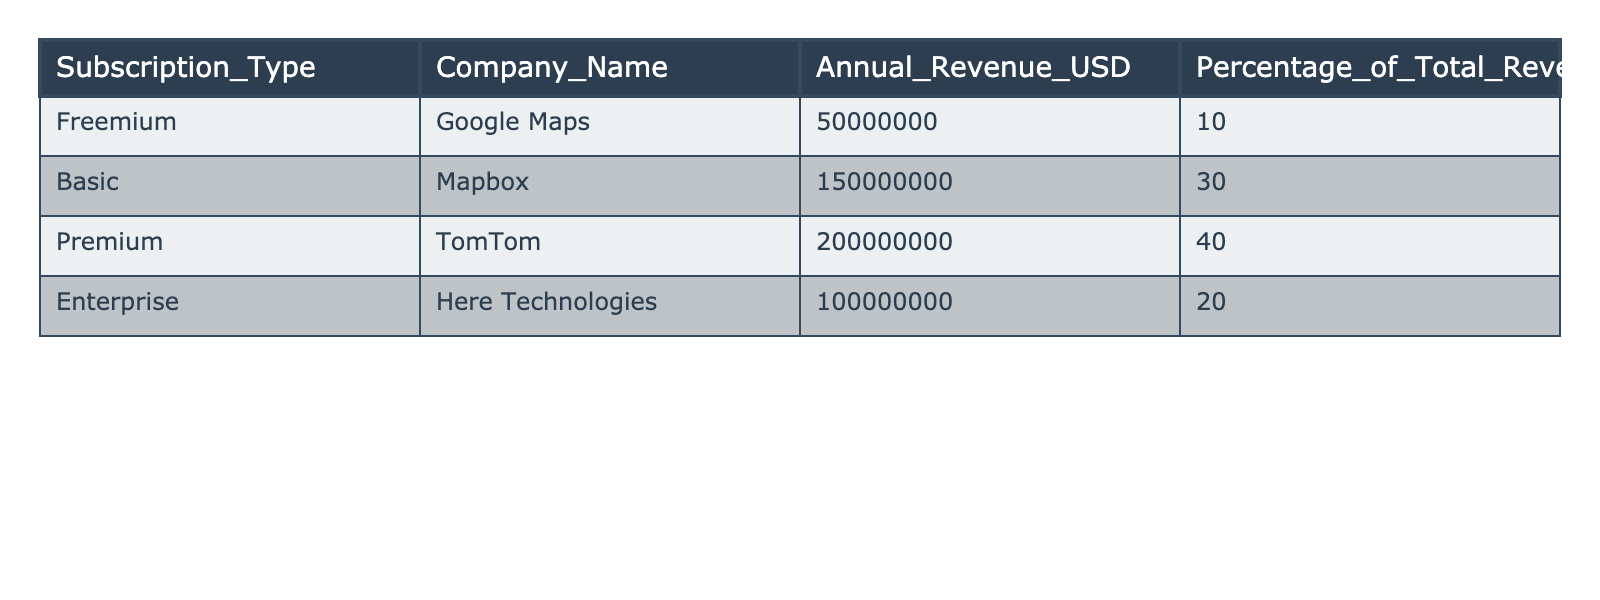What is the total annual revenue from all subscription types? To find the total annual revenue, sum the revenues from all subscription types: 50,000,000 + 150,000,000 + 200,000,000 + 100,000,000 = 500,000,000.
Answer: 500,000,000 Which subscription type generates the highest annual revenue? The subscription type with the highest annual revenue is Premium with 200,000,000.
Answer: Premium What percentage of the total revenue does the Basic subscription account for? The Basic subscription accounts for 30% of the total revenue.
Answer: 30% Is the annual revenue from the Freemium subscription less than 10% of the total revenue? The annual revenue from the Freemium subscription is 50,000,000, which is 10% of the total revenue, so it is not less.
Answer: No What is the combined annual revenue of Enterprise and Freemium subscriptions? Add the annual revenues of Enterprise (100,000,000) and Freemium (50,000,000): 100,000,000 + 50,000,000 = 150,000,000.
Answer: 150,000,000 Which subscription types collectively make up more than 70% of the total revenue? The Basic (30%) and Premium (40%) subscription types collectively make up 70%, while adding the Enterprise (20%) gives 90%, thus all three combined exceed 70%.
Answer: Basic, Premium, and Enterprise What is the difference in annual revenue between the Premium and Enterprise subscriptions? The difference is 200,000,000 (Premium) - 100,000,000 (Enterprise) = 100,000,000.
Answer: 100,000,000 Which company has the lowest percentage of total revenue among the listed subscriptions? Freemium (Google Maps) has the lowest percentage of total revenue at 10%.
Answer: Freemium How much revenue would be lost if all Freemium subscriptions were eliminated? If Freemium (50,000,000) were eliminated, the total revenue would decrease by this amount: 500,000,000 - 50,000,000 = 450,000,000.
Answer: 50,000,000 Which subscription types have a combined revenue that is equal to the revenue from the Premium subscription? The combination of Basic (150,000,000) and Freemium (50,000,000) yields 200,000,000, which equals the revenue from Premium.
Answer: Basic and Freemium 